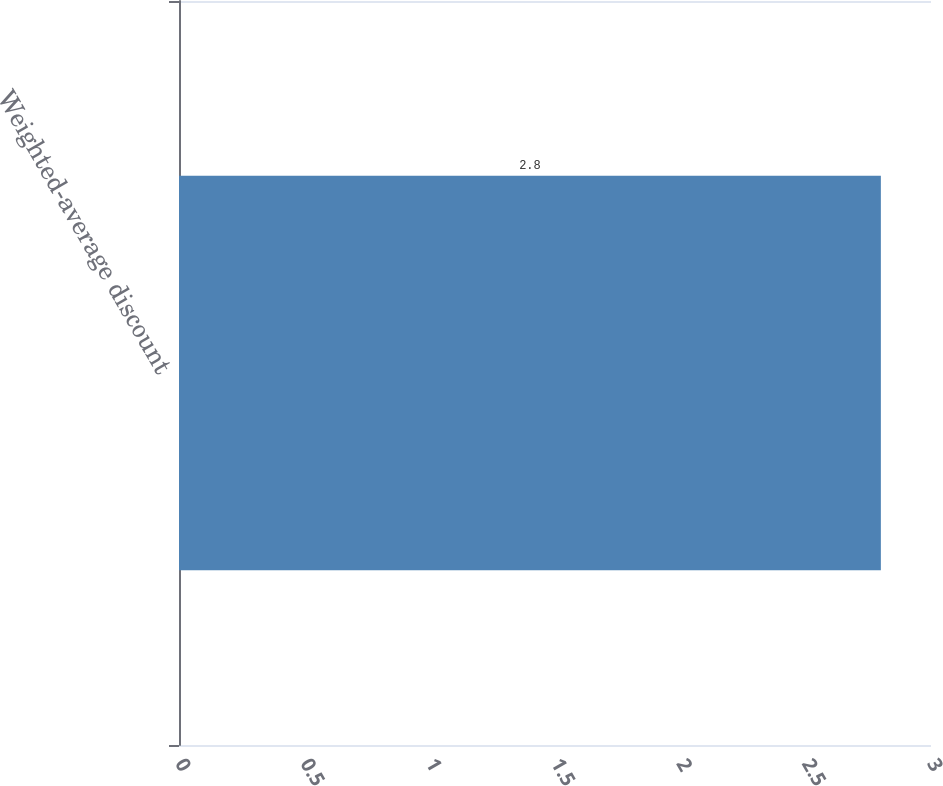<chart> <loc_0><loc_0><loc_500><loc_500><bar_chart><fcel>Weighted-average discount<nl><fcel>2.8<nl></chart> 